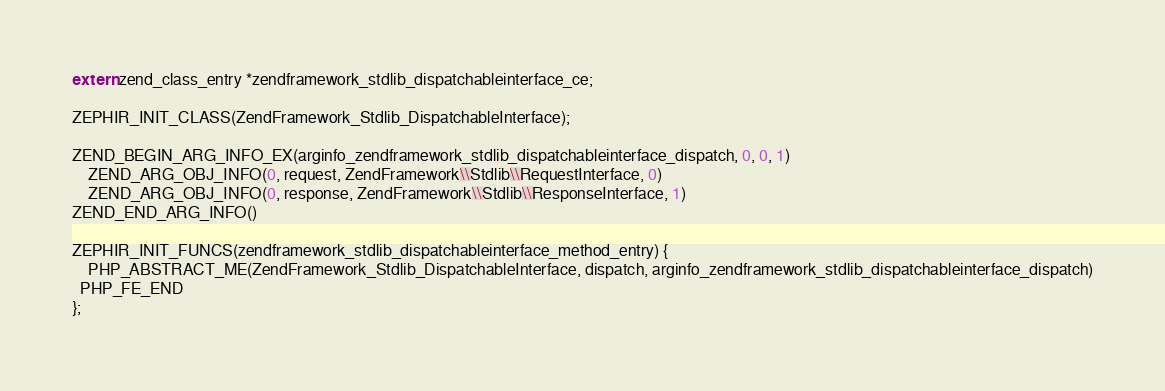<code> <loc_0><loc_0><loc_500><loc_500><_C_>
extern zend_class_entry *zendframework_stdlib_dispatchableinterface_ce;

ZEPHIR_INIT_CLASS(ZendFramework_Stdlib_DispatchableInterface);

ZEND_BEGIN_ARG_INFO_EX(arginfo_zendframework_stdlib_dispatchableinterface_dispatch, 0, 0, 1)
	ZEND_ARG_OBJ_INFO(0, request, ZendFramework\\Stdlib\\RequestInterface, 0)
	ZEND_ARG_OBJ_INFO(0, response, ZendFramework\\Stdlib\\ResponseInterface, 1)
ZEND_END_ARG_INFO()

ZEPHIR_INIT_FUNCS(zendframework_stdlib_dispatchableinterface_method_entry) {
	PHP_ABSTRACT_ME(ZendFramework_Stdlib_DispatchableInterface, dispatch, arginfo_zendframework_stdlib_dispatchableinterface_dispatch)
  PHP_FE_END
};
</code> 